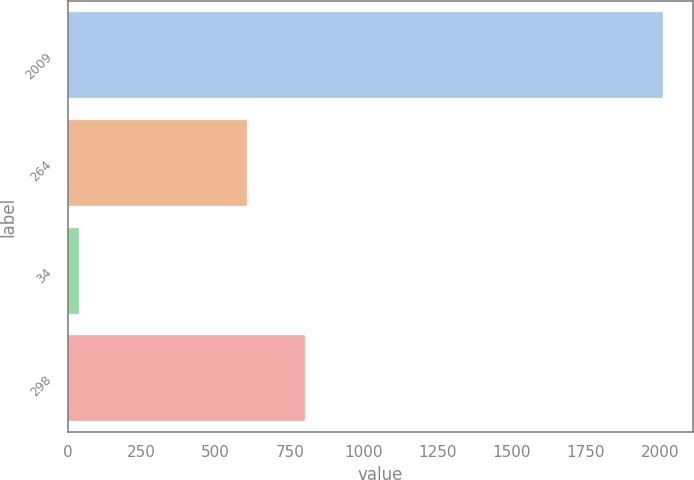Convert chart. <chart><loc_0><loc_0><loc_500><loc_500><bar_chart><fcel>2009<fcel>264<fcel>34<fcel>298<nl><fcel>2012<fcel>605<fcel>39<fcel>802.3<nl></chart> 